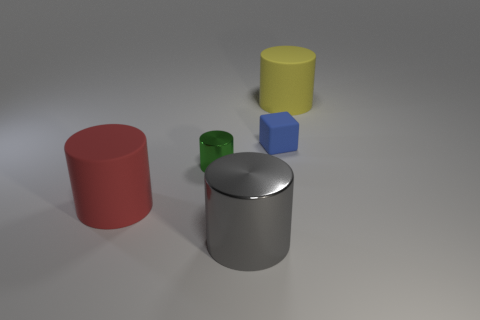What size is the green shiny object that is the same shape as the red matte thing?
Provide a succinct answer. Small. Is there a block?
Keep it short and to the point. Yes. How big is the matte cylinder that is to the left of the big rubber object that is on the right side of the small thing that is behind the green shiny thing?
Your response must be concise. Large. What number of things are either yellow matte things or objects left of the small blue object?
Offer a very short reply. 4. What color is the big shiny thing?
Offer a terse response. Gray. The large thing that is behind the blue cube is what color?
Ensure brevity in your answer.  Yellow. There is a gray shiny object in front of the yellow matte thing; how many small blue matte blocks are to the right of it?
Give a very brief answer. 1. Do the gray object and the rubber cylinder behind the small cube have the same size?
Offer a very short reply. Yes. Are there any cylinders of the same size as the yellow object?
Your answer should be compact. Yes. How many things are red rubber cylinders or big metal objects?
Give a very brief answer. 2. 